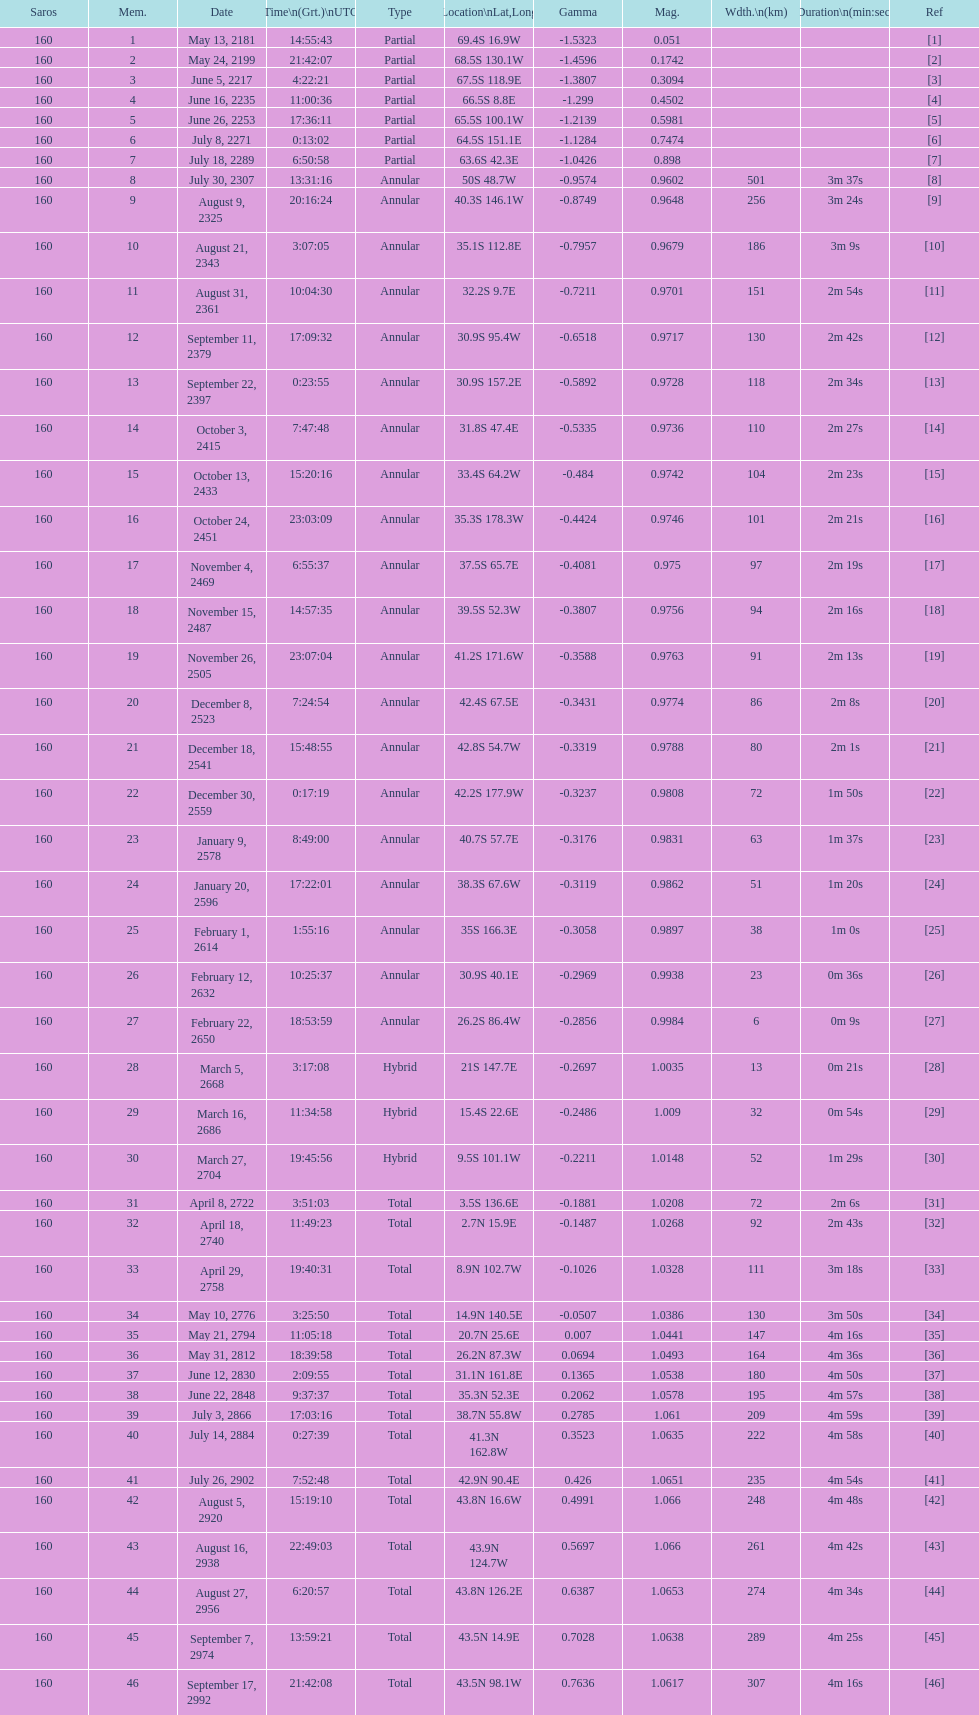How many partial members will occur before the first annular? 7. Can you parse all the data within this table? {'header': ['Saros', 'Mem.', 'Date', 'Time\\n(Grt.)\\nUTC', 'Type', 'Location\\nLat,Long', 'Gamma', 'Mag.', 'Wdth.\\n(km)', 'Duration\\n(min:sec)', 'Ref'], 'rows': [['160', '1', 'May 13, 2181', '14:55:43', 'Partial', '69.4S 16.9W', '-1.5323', '0.051', '', '', '[1]'], ['160', '2', 'May 24, 2199', '21:42:07', 'Partial', '68.5S 130.1W', '-1.4596', '0.1742', '', '', '[2]'], ['160', '3', 'June 5, 2217', '4:22:21', 'Partial', '67.5S 118.9E', '-1.3807', '0.3094', '', '', '[3]'], ['160', '4', 'June 16, 2235', '11:00:36', 'Partial', '66.5S 8.8E', '-1.299', '0.4502', '', '', '[4]'], ['160', '5', 'June 26, 2253', '17:36:11', 'Partial', '65.5S 100.1W', '-1.2139', '0.5981', '', '', '[5]'], ['160', '6', 'July 8, 2271', '0:13:02', 'Partial', '64.5S 151.1E', '-1.1284', '0.7474', '', '', '[6]'], ['160', '7', 'July 18, 2289', '6:50:58', 'Partial', '63.6S 42.3E', '-1.0426', '0.898', '', '', '[7]'], ['160', '8', 'July 30, 2307', '13:31:16', 'Annular', '50S 48.7W', '-0.9574', '0.9602', '501', '3m 37s', '[8]'], ['160', '9', 'August 9, 2325', '20:16:24', 'Annular', '40.3S 146.1W', '-0.8749', '0.9648', '256', '3m 24s', '[9]'], ['160', '10', 'August 21, 2343', '3:07:05', 'Annular', '35.1S 112.8E', '-0.7957', '0.9679', '186', '3m 9s', '[10]'], ['160', '11', 'August 31, 2361', '10:04:30', 'Annular', '32.2S 9.7E', '-0.7211', '0.9701', '151', '2m 54s', '[11]'], ['160', '12', 'September 11, 2379', '17:09:32', 'Annular', '30.9S 95.4W', '-0.6518', '0.9717', '130', '2m 42s', '[12]'], ['160', '13', 'September 22, 2397', '0:23:55', 'Annular', '30.9S 157.2E', '-0.5892', '0.9728', '118', '2m 34s', '[13]'], ['160', '14', 'October 3, 2415', '7:47:48', 'Annular', '31.8S 47.4E', '-0.5335', '0.9736', '110', '2m 27s', '[14]'], ['160', '15', 'October 13, 2433', '15:20:16', 'Annular', '33.4S 64.2W', '-0.484', '0.9742', '104', '2m 23s', '[15]'], ['160', '16', 'October 24, 2451', '23:03:09', 'Annular', '35.3S 178.3W', '-0.4424', '0.9746', '101', '2m 21s', '[16]'], ['160', '17', 'November 4, 2469', '6:55:37', 'Annular', '37.5S 65.7E', '-0.4081', '0.975', '97', '2m 19s', '[17]'], ['160', '18', 'November 15, 2487', '14:57:35', 'Annular', '39.5S 52.3W', '-0.3807', '0.9756', '94', '2m 16s', '[18]'], ['160', '19', 'November 26, 2505', '23:07:04', 'Annular', '41.2S 171.6W', '-0.3588', '0.9763', '91', '2m 13s', '[19]'], ['160', '20', 'December 8, 2523', '7:24:54', 'Annular', '42.4S 67.5E', '-0.3431', '0.9774', '86', '2m 8s', '[20]'], ['160', '21', 'December 18, 2541', '15:48:55', 'Annular', '42.8S 54.7W', '-0.3319', '0.9788', '80', '2m 1s', '[21]'], ['160', '22', 'December 30, 2559', '0:17:19', 'Annular', '42.2S 177.9W', '-0.3237', '0.9808', '72', '1m 50s', '[22]'], ['160', '23', 'January 9, 2578', '8:49:00', 'Annular', '40.7S 57.7E', '-0.3176', '0.9831', '63', '1m 37s', '[23]'], ['160', '24', 'January 20, 2596', '17:22:01', 'Annular', '38.3S 67.6W', '-0.3119', '0.9862', '51', '1m 20s', '[24]'], ['160', '25', 'February 1, 2614', '1:55:16', 'Annular', '35S 166.3E', '-0.3058', '0.9897', '38', '1m 0s', '[25]'], ['160', '26', 'February 12, 2632', '10:25:37', 'Annular', '30.9S 40.1E', '-0.2969', '0.9938', '23', '0m 36s', '[26]'], ['160', '27', 'February 22, 2650', '18:53:59', 'Annular', '26.2S 86.4W', '-0.2856', '0.9984', '6', '0m 9s', '[27]'], ['160', '28', 'March 5, 2668', '3:17:08', 'Hybrid', '21S 147.7E', '-0.2697', '1.0035', '13', '0m 21s', '[28]'], ['160', '29', 'March 16, 2686', '11:34:58', 'Hybrid', '15.4S 22.6E', '-0.2486', '1.009', '32', '0m 54s', '[29]'], ['160', '30', 'March 27, 2704', '19:45:56', 'Hybrid', '9.5S 101.1W', '-0.2211', '1.0148', '52', '1m 29s', '[30]'], ['160', '31', 'April 8, 2722', '3:51:03', 'Total', '3.5S 136.6E', '-0.1881', '1.0208', '72', '2m 6s', '[31]'], ['160', '32', 'April 18, 2740', '11:49:23', 'Total', '2.7N 15.9E', '-0.1487', '1.0268', '92', '2m 43s', '[32]'], ['160', '33', 'April 29, 2758', '19:40:31', 'Total', '8.9N 102.7W', '-0.1026', '1.0328', '111', '3m 18s', '[33]'], ['160', '34', 'May 10, 2776', '3:25:50', 'Total', '14.9N 140.5E', '-0.0507', '1.0386', '130', '3m 50s', '[34]'], ['160', '35', 'May 21, 2794', '11:05:18', 'Total', '20.7N 25.6E', '0.007', '1.0441', '147', '4m 16s', '[35]'], ['160', '36', 'May 31, 2812', '18:39:58', 'Total', '26.2N 87.3W', '0.0694', '1.0493', '164', '4m 36s', '[36]'], ['160', '37', 'June 12, 2830', '2:09:55', 'Total', '31.1N 161.8E', '0.1365', '1.0538', '180', '4m 50s', '[37]'], ['160', '38', 'June 22, 2848', '9:37:37', 'Total', '35.3N 52.3E', '0.2062', '1.0578', '195', '4m 57s', '[38]'], ['160', '39', 'July 3, 2866', '17:03:16', 'Total', '38.7N 55.8W', '0.2785', '1.061', '209', '4m 59s', '[39]'], ['160', '40', 'July 14, 2884', '0:27:39', 'Total', '41.3N 162.8W', '0.3523', '1.0635', '222', '4m 58s', '[40]'], ['160', '41', 'July 26, 2902', '7:52:48', 'Total', '42.9N 90.4E', '0.426', '1.0651', '235', '4m 54s', '[41]'], ['160', '42', 'August 5, 2920', '15:19:10', 'Total', '43.8N 16.6W', '0.4991', '1.066', '248', '4m 48s', '[42]'], ['160', '43', 'August 16, 2938', '22:49:03', 'Total', '43.9N 124.7W', '0.5697', '1.066', '261', '4m 42s', '[43]'], ['160', '44', 'August 27, 2956', '6:20:57', 'Total', '43.8N 126.2E', '0.6387', '1.0653', '274', '4m 34s', '[44]'], ['160', '45', 'September 7, 2974', '13:59:21', 'Total', '43.5N 14.9E', '0.7028', '1.0638', '289', '4m 25s', '[45]'], ['160', '46', 'September 17, 2992', '21:42:08', 'Total', '43.5N 98.1W', '0.7636', '1.0617', '307', '4m 16s', '[46]']]} 